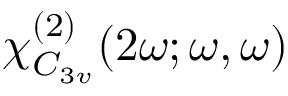Convert formula to latex. <formula><loc_0><loc_0><loc_500><loc_500>\boldsymbol \chi _ { C _ { 3 v } } ^ { ( 2 ) } ( 2 \omega ; \omega , \omega )</formula> 